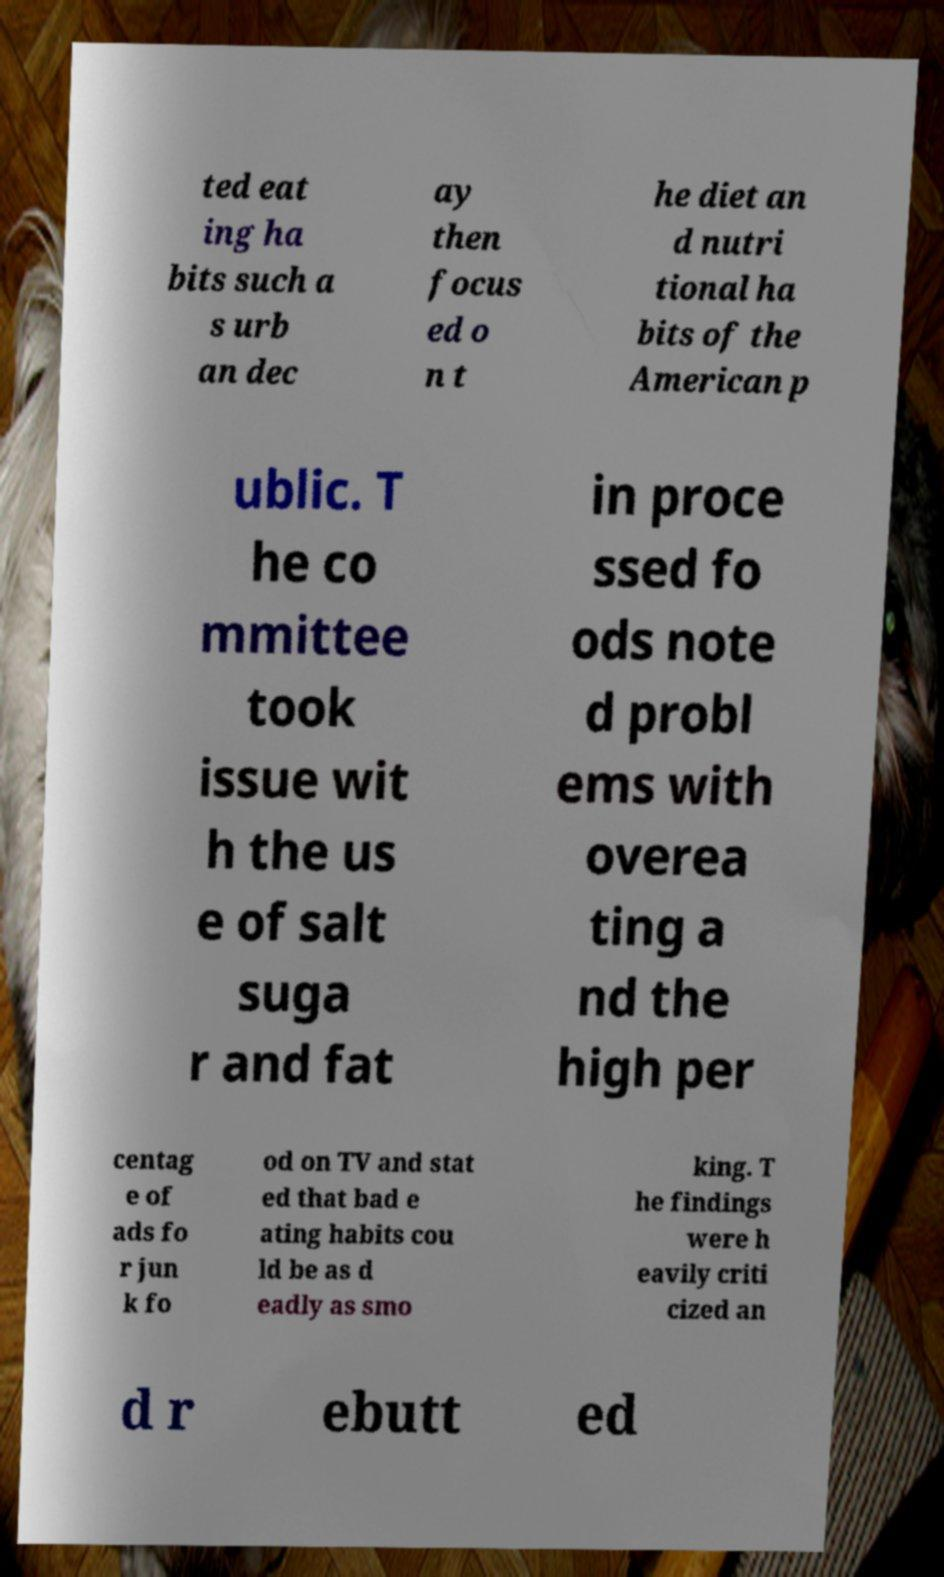Can you read and provide the text displayed in the image?This photo seems to have some interesting text. Can you extract and type it out for me? ted eat ing ha bits such a s urb an dec ay then focus ed o n t he diet an d nutri tional ha bits of the American p ublic. T he co mmittee took issue wit h the us e of salt suga r and fat in proce ssed fo ods note d probl ems with overea ting a nd the high per centag e of ads fo r jun k fo od on TV and stat ed that bad e ating habits cou ld be as d eadly as smo king. T he findings were h eavily criti cized an d r ebutt ed 